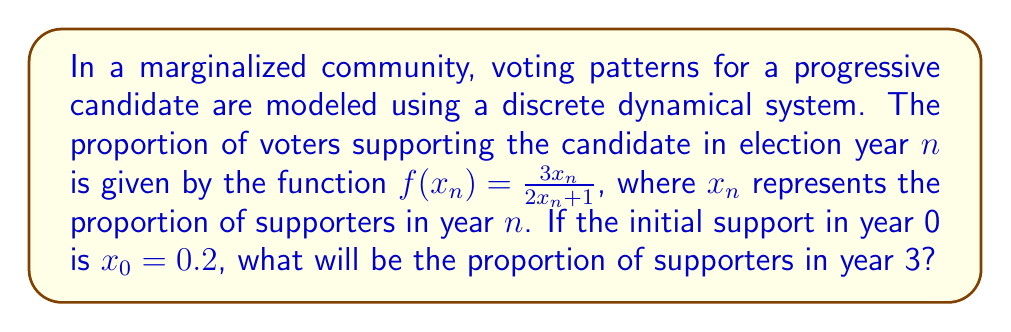Teach me how to tackle this problem. To solve this problem, we need to iterate the given function three times, starting with $x_0 = 0.2$. Let's go through it step-by-step:

1. For year 1 ($n = 1$):
   $$x_1 = f(x_0) = \frac{3(0.2)}{2(0.2) + 1} = \frac{0.6}{1.4} \approx 0.4286$$

2. For year 2 ($n = 2$):
   $$x_2 = f(x_1) = \frac{3(0.4286)}{2(0.4286) + 1} = \frac{1.2858}{1.8572} \approx 0.6924$$

3. For year 3 ($n = 3$):
   $$x_3 = f(x_2) = \frac{3(0.6924)}{2(0.6924) + 1} = \frac{2.0772}{2.3848} \approx 0.8710$$

Therefore, the proportion of supporters in year 3 will be approximately 0.8710 or 87.10%.
Answer: 0.8710 